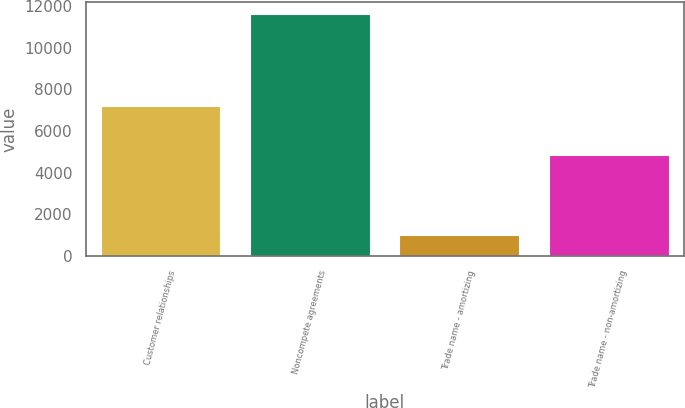Convert chart. <chart><loc_0><loc_0><loc_500><loc_500><bar_chart><fcel>Customer relationships<fcel>Noncompete agreements<fcel>Trade name - amortizing<fcel>Trade name - non-amortizing<nl><fcel>7207<fcel>11608<fcel>995<fcel>4868<nl></chart> 